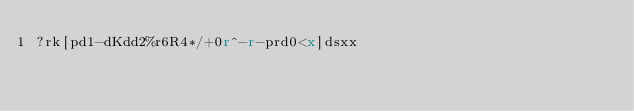Convert code to text. <code><loc_0><loc_0><loc_500><loc_500><_dc_>?rk[pd1-dKdd2%r6R4*/+0r^-r-prd0<x]dsxx</code> 